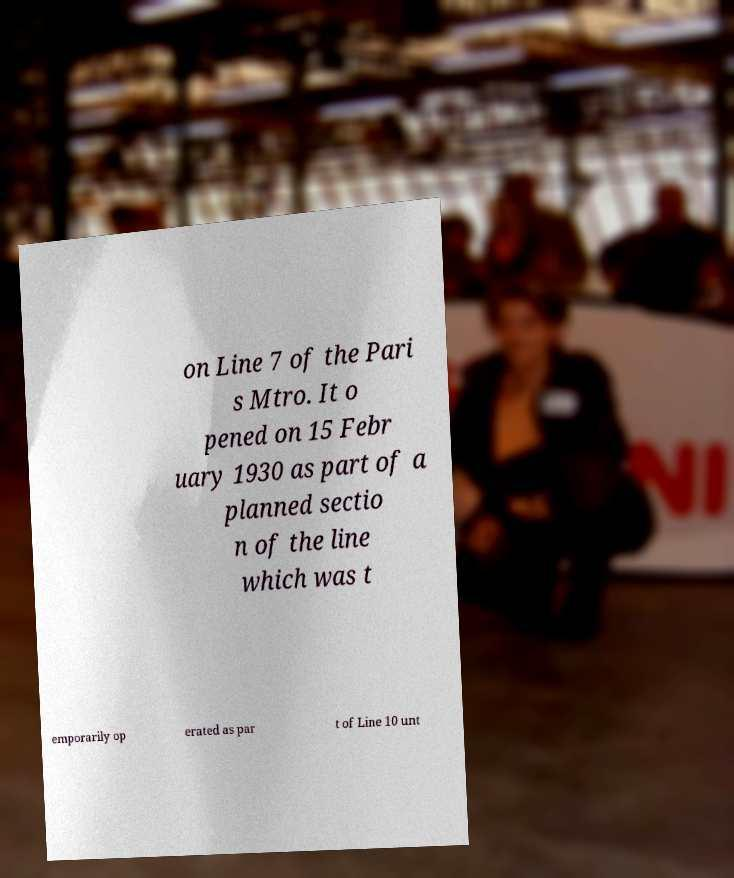Can you accurately transcribe the text from the provided image for me? on Line 7 of the Pari s Mtro. It o pened on 15 Febr uary 1930 as part of a planned sectio n of the line which was t emporarily op erated as par t of Line 10 unt 